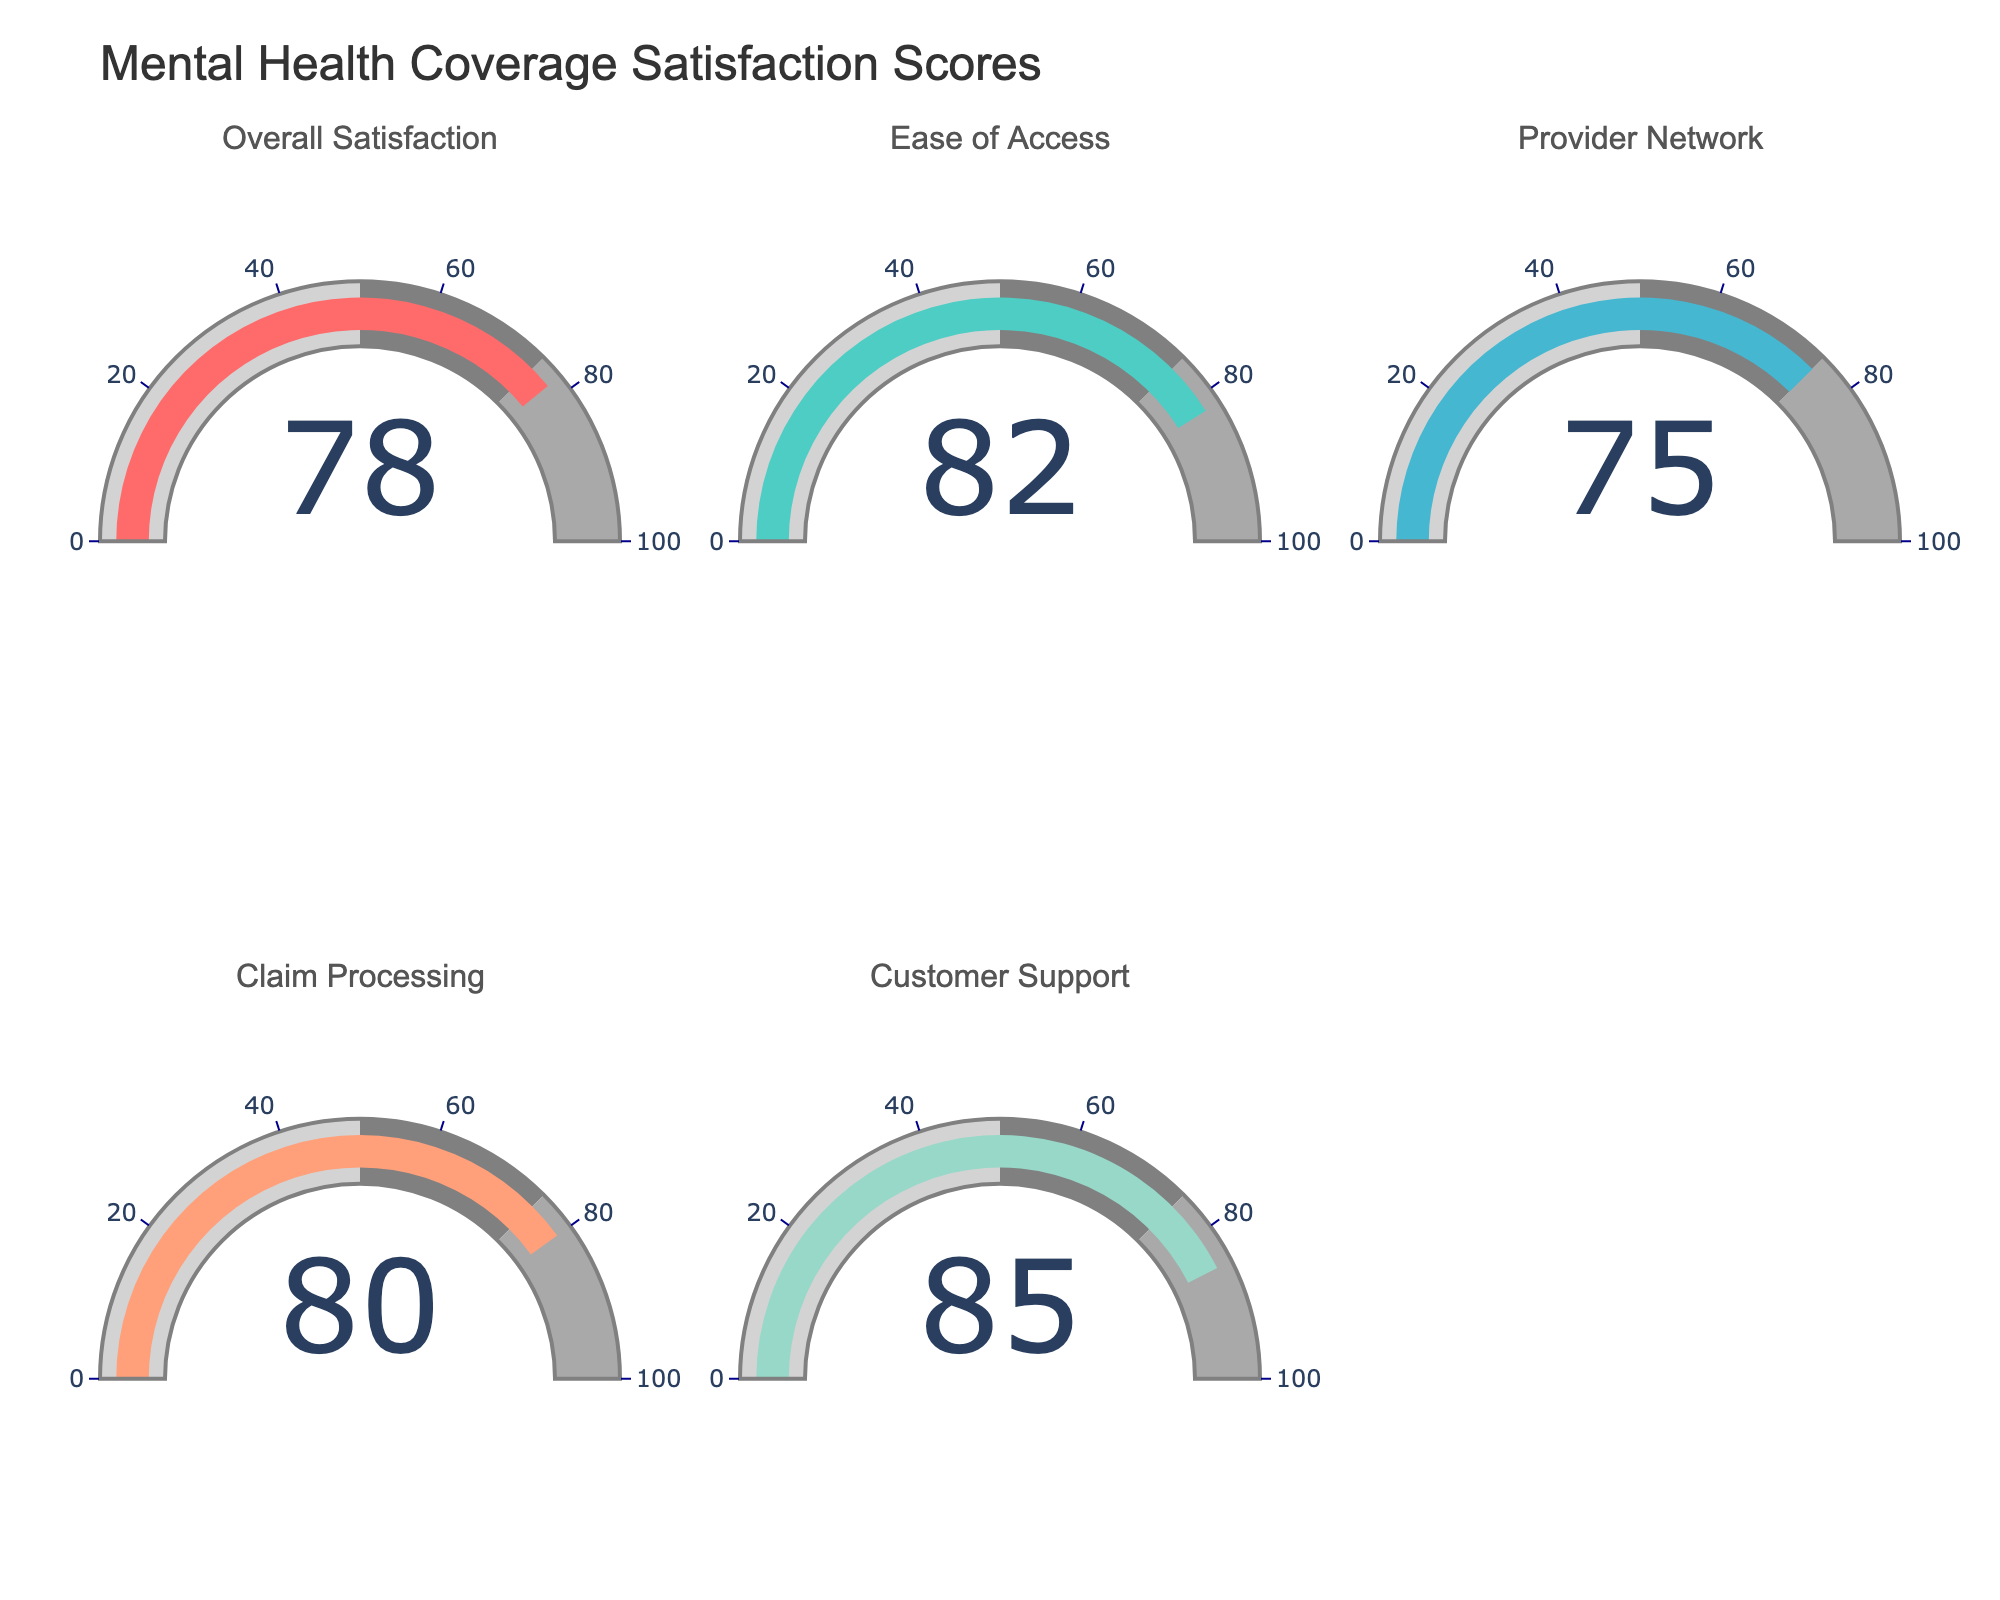What is the overall satisfaction score? Look at the gauge labeled "Overall Satisfaction" and read the score displayed.
Answer: 78 Which category has the highest satisfaction score? Compare the scores displayed for each category and identify the highest one.
Answer: Customer Support How does the satisfaction score for Ease of Access compare to the Provider Network? Look at the scores for both categories: Ease of Access has a score of 82, and Provider Network has a score of 75. 82 is greater than 75.
Answer: Ease of Access is higher What is the average satisfaction score across all categories? Sum up all the satisfaction scores (78 + 82 + 75 + 80 + 85) and divide by the number of categories (5). The total is 400, so the average is 400/5.
Answer: 80 How much higher is the Customer Support score compared to the Claim Processing score? Subtract the score for Claim Processing (80) from the score for Customer Support (85). 85 - 80 = 5.
Answer: 5 Which category has the lowest satisfaction score? Compare all the scores and identify the lowest one, which is 75 for Provider Network.
Answer: Provider Network What is the median satisfaction score? Arrange the scores in ascending order: 75, 78, 80, 82, 85. The median is the middle value, which is 80.
Answer: 80 Does any category have a score below 80? Check all the displayed scores to see if any are below 80. The Provider Network has a score of 75, which is below 80.
Answer: Yes How many categories have scores greater than 80? Count the number of categories that have scores above 80. There are three such categories: Ease of Access (82), Claim Processing (80), and Customer Support (85).
Answer: 3 What percentage of categories have a satisfaction score above 75? First count the number of categories with a score above 75 (all: 5 categories). Then, calculate the percentage: (5/5) * 100 = 100%.
Answer: 100% 